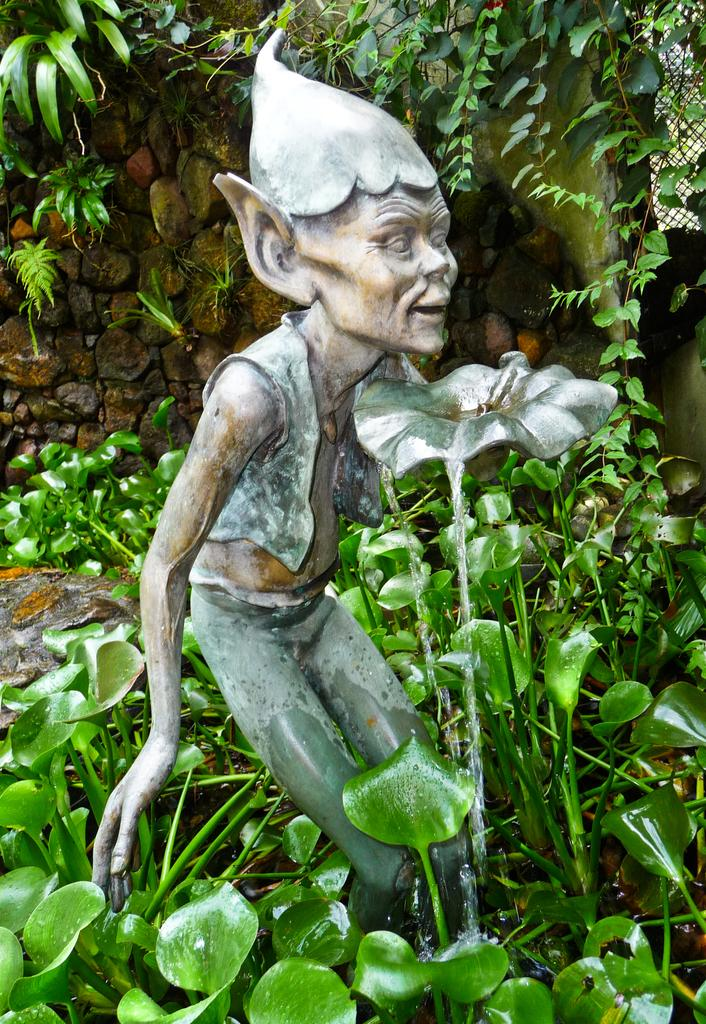What is the main subject of the image? There is a sculpture in the image. What is happening to the sculpture? Water is falling from the sculpture. What type of vegetation is present in the image? Plants are present at the bottom and top of the image. What type of sound does the potato make when it hits the nail in the image? There is no potato or nail present in the image, so it is not possible to determine the sound made by a potato hitting a nail. 